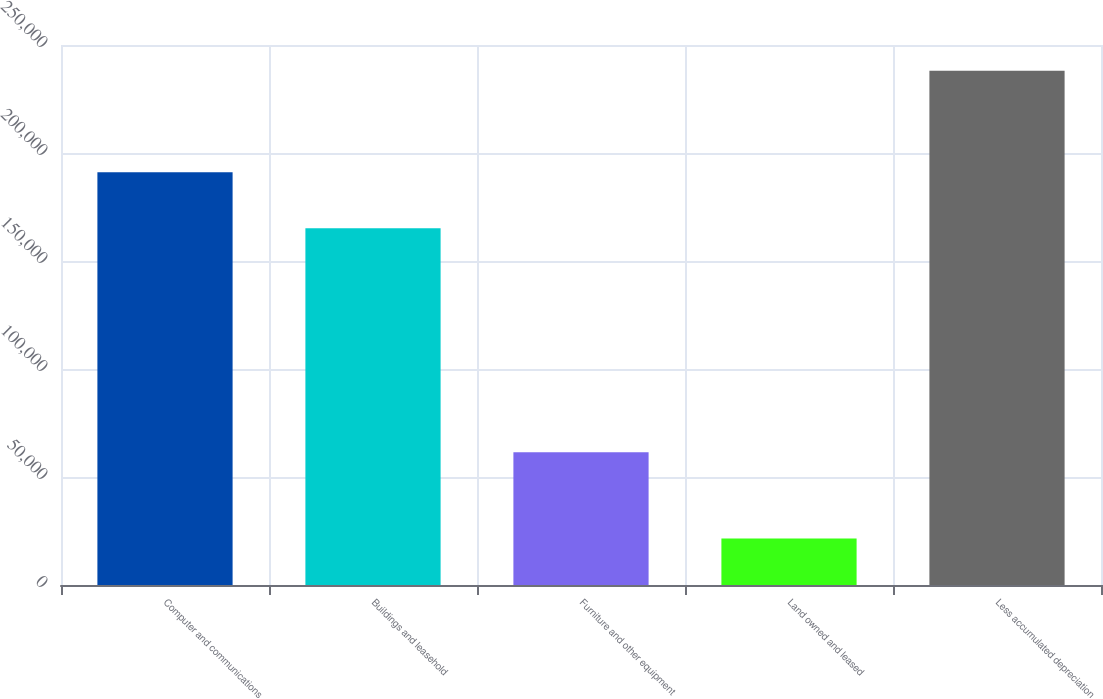Convert chart to OTSL. <chart><loc_0><loc_0><loc_500><loc_500><bar_chart><fcel>Computer and communications<fcel>Buildings and leasehold<fcel>Furniture and other equipment<fcel>Land owned and leased<fcel>Less accumulated depreciation<nl><fcel>191118<fcel>165127<fcel>61479<fcel>21503<fcel>238133<nl></chart> 